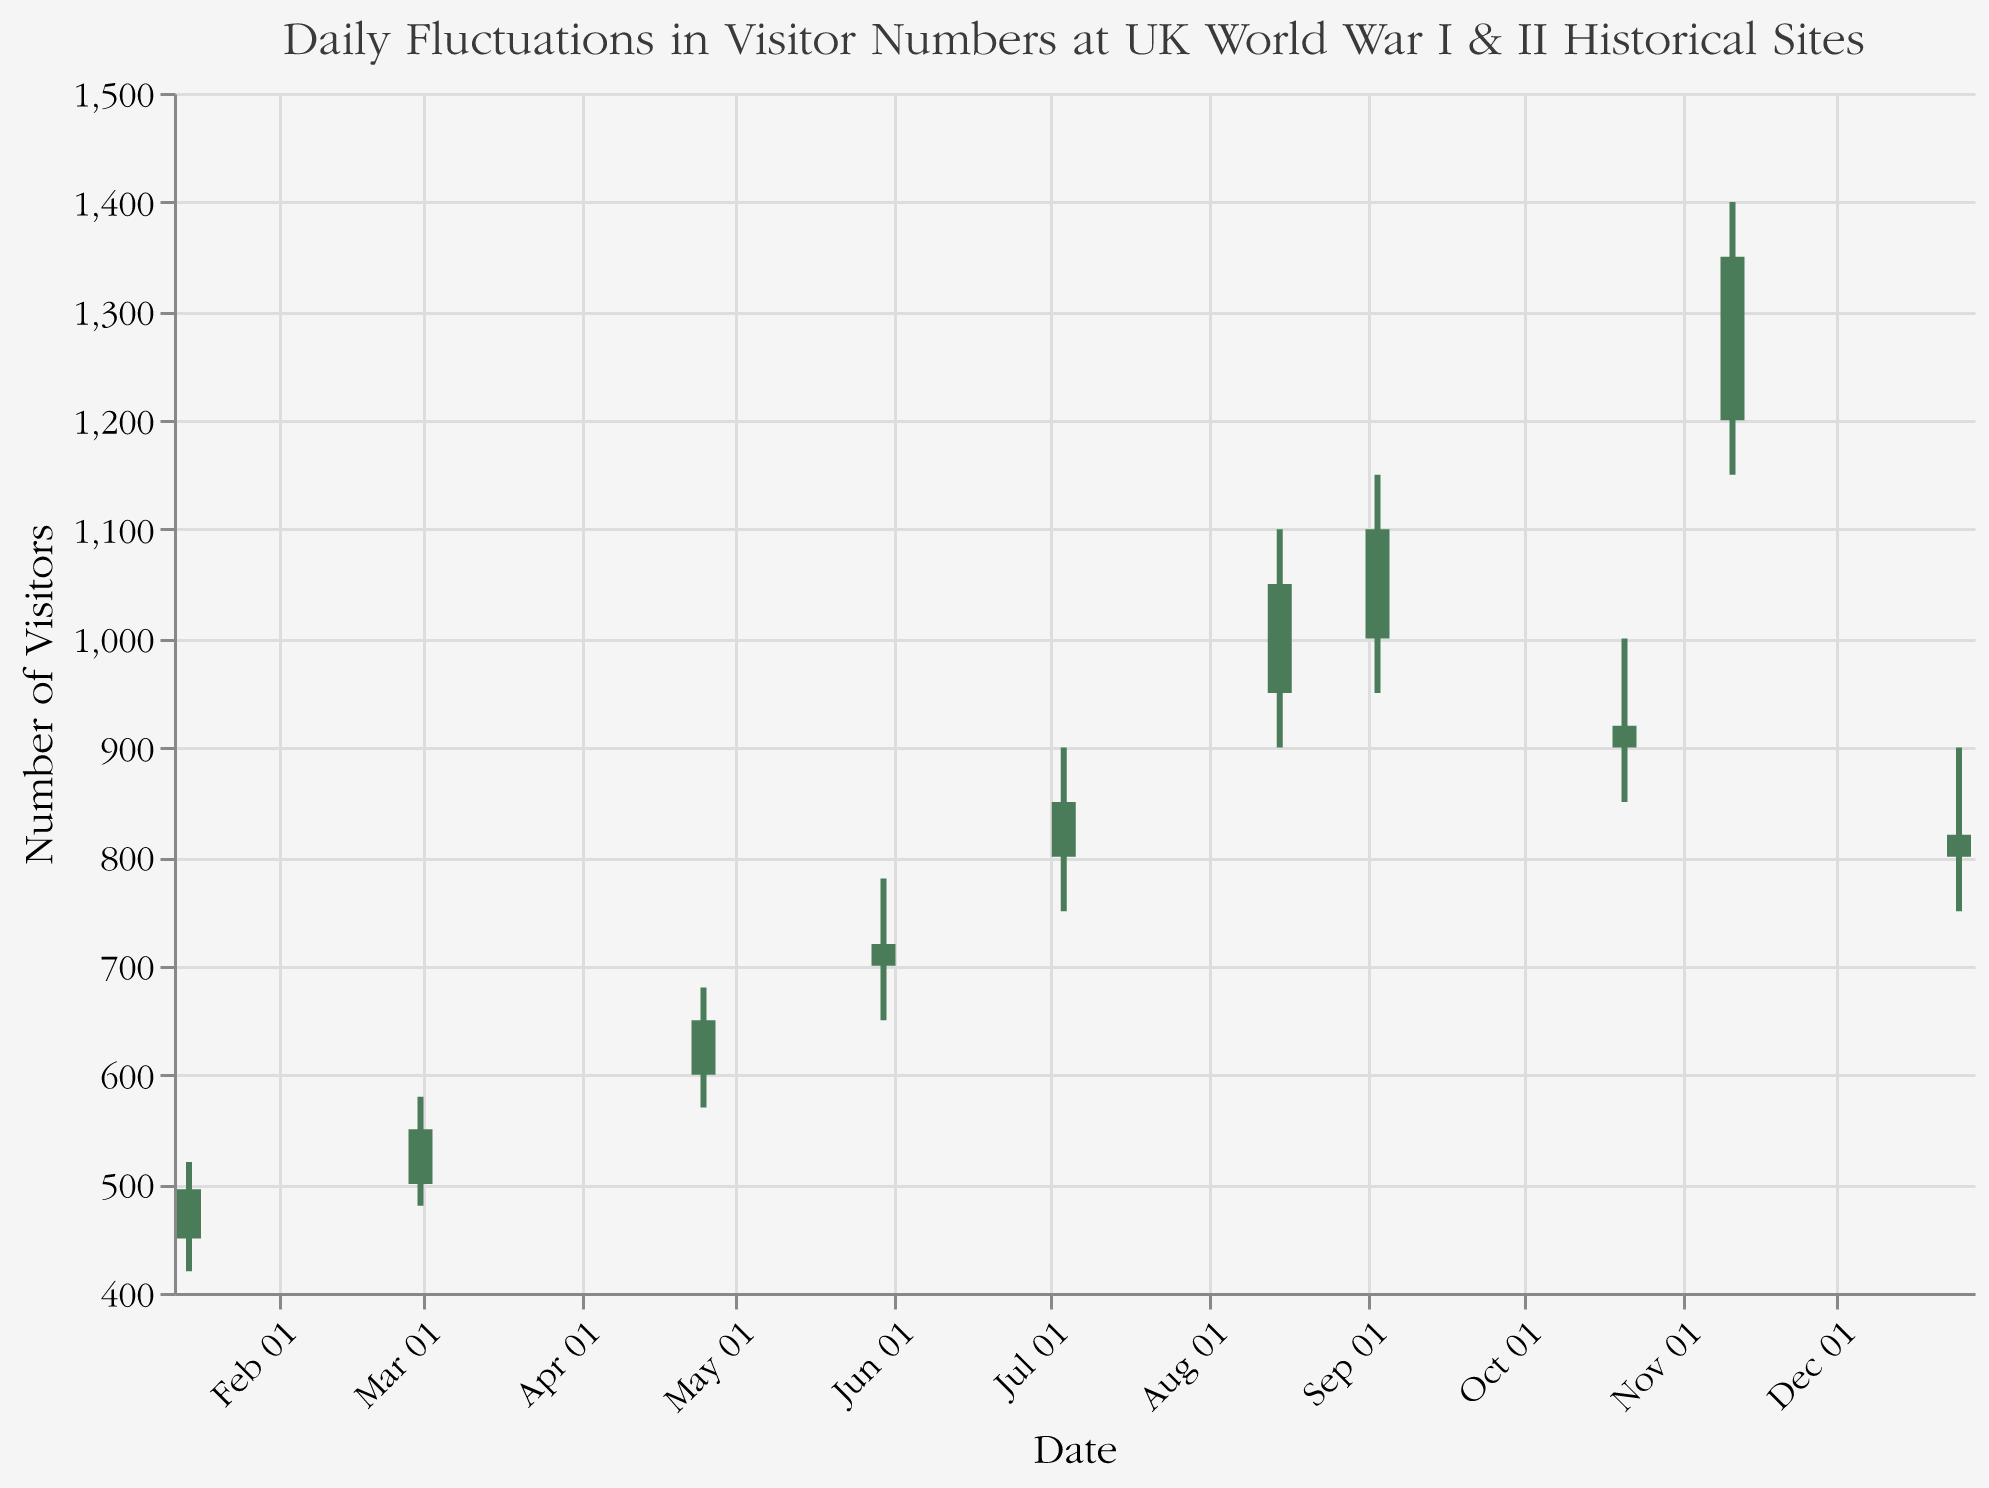What is the highest number of visitors recorded on any single day? The highest number of visitors can be seen from the "High" values of each date. The highest value is 1400 on November 11.
Answer: 1400 On which date did the number of visitors close the highest at the end of the day? Looking at the "Close" values for each date, the highest value is 1350 on November 11.
Answer: November 11 Compare the number of visitors on July 4 and August 15. Which day had more visitors at the beginning of the day? The "Open" value for July 4 is 800, and for August 15, it is 950. Therefore, August 15 had more visitors at the beginning of the day.
Answer: August 15 What was the range of visitor numbers on October 21? The range can be calculated by subtracting the "Low" value from the "High" value on October 21. The values are: High = 1000, Low = 850 so the range is 1000 - 850 = 150.
Answer: 150 On which date did the number of visitors fall from the opening count to the closing count? We need to find dates where the "Close" value is less than the "Open" value. This occurs on January 15 (450 to 495), October 21 (900 to 920), and December 25 (800 to 820).
Answer: January 15, October 21, December 25 What is the difference between the highest and lowest "Open" values in the dataset? The highest "Open" value is 1200 on November 11, and the lowest "Open" value is 450 on January 15. The difference is 1200 - 450 = 750.
Answer: 750 Which date had the smallest fluctuation in the number of visitors throughout the day? The smallest fluctuation can be found by looking at the differences between the "High" and "Low" values. The smallest difference is on December 25 (High 900 - Low 750 = 150).
Answer: December 25 Was there any date on which the number of visitors both opened and closed lower than the previous date? To find this, look at pairs of consecutive dates. February 28 (before March 1) and August 14 (before August 15) are the dates to consider. Both February 28 and August 14 have no data, so no such date exists based on the provided dataset.
Answer: No What was the average "Close" value for all the dates combined? To find the average, sum all the "Close" values and divide by the number of dates. The total "Close" values are 495 + 550 + 650 + 720 + 850 + 1050 + 1100 + 920 + 1350 + 820 = 8505. There are 10 dates, so the average is 8505 / 10 = 850.5.
Answer: 850.5 